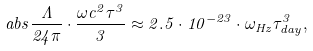<formula> <loc_0><loc_0><loc_500><loc_500>\ a b s { \frac { \Lambda } { 2 4 \pi } \cdot \frac { \omega c ^ { 2 } \tau ^ { 3 } } { 3 } } \approx 2 . 5 \cdot 1 0 ^ { - 2 3 } \cdot \omega _ { H z } \tau _ { d a y } ^ { 3 } ,</formula> 